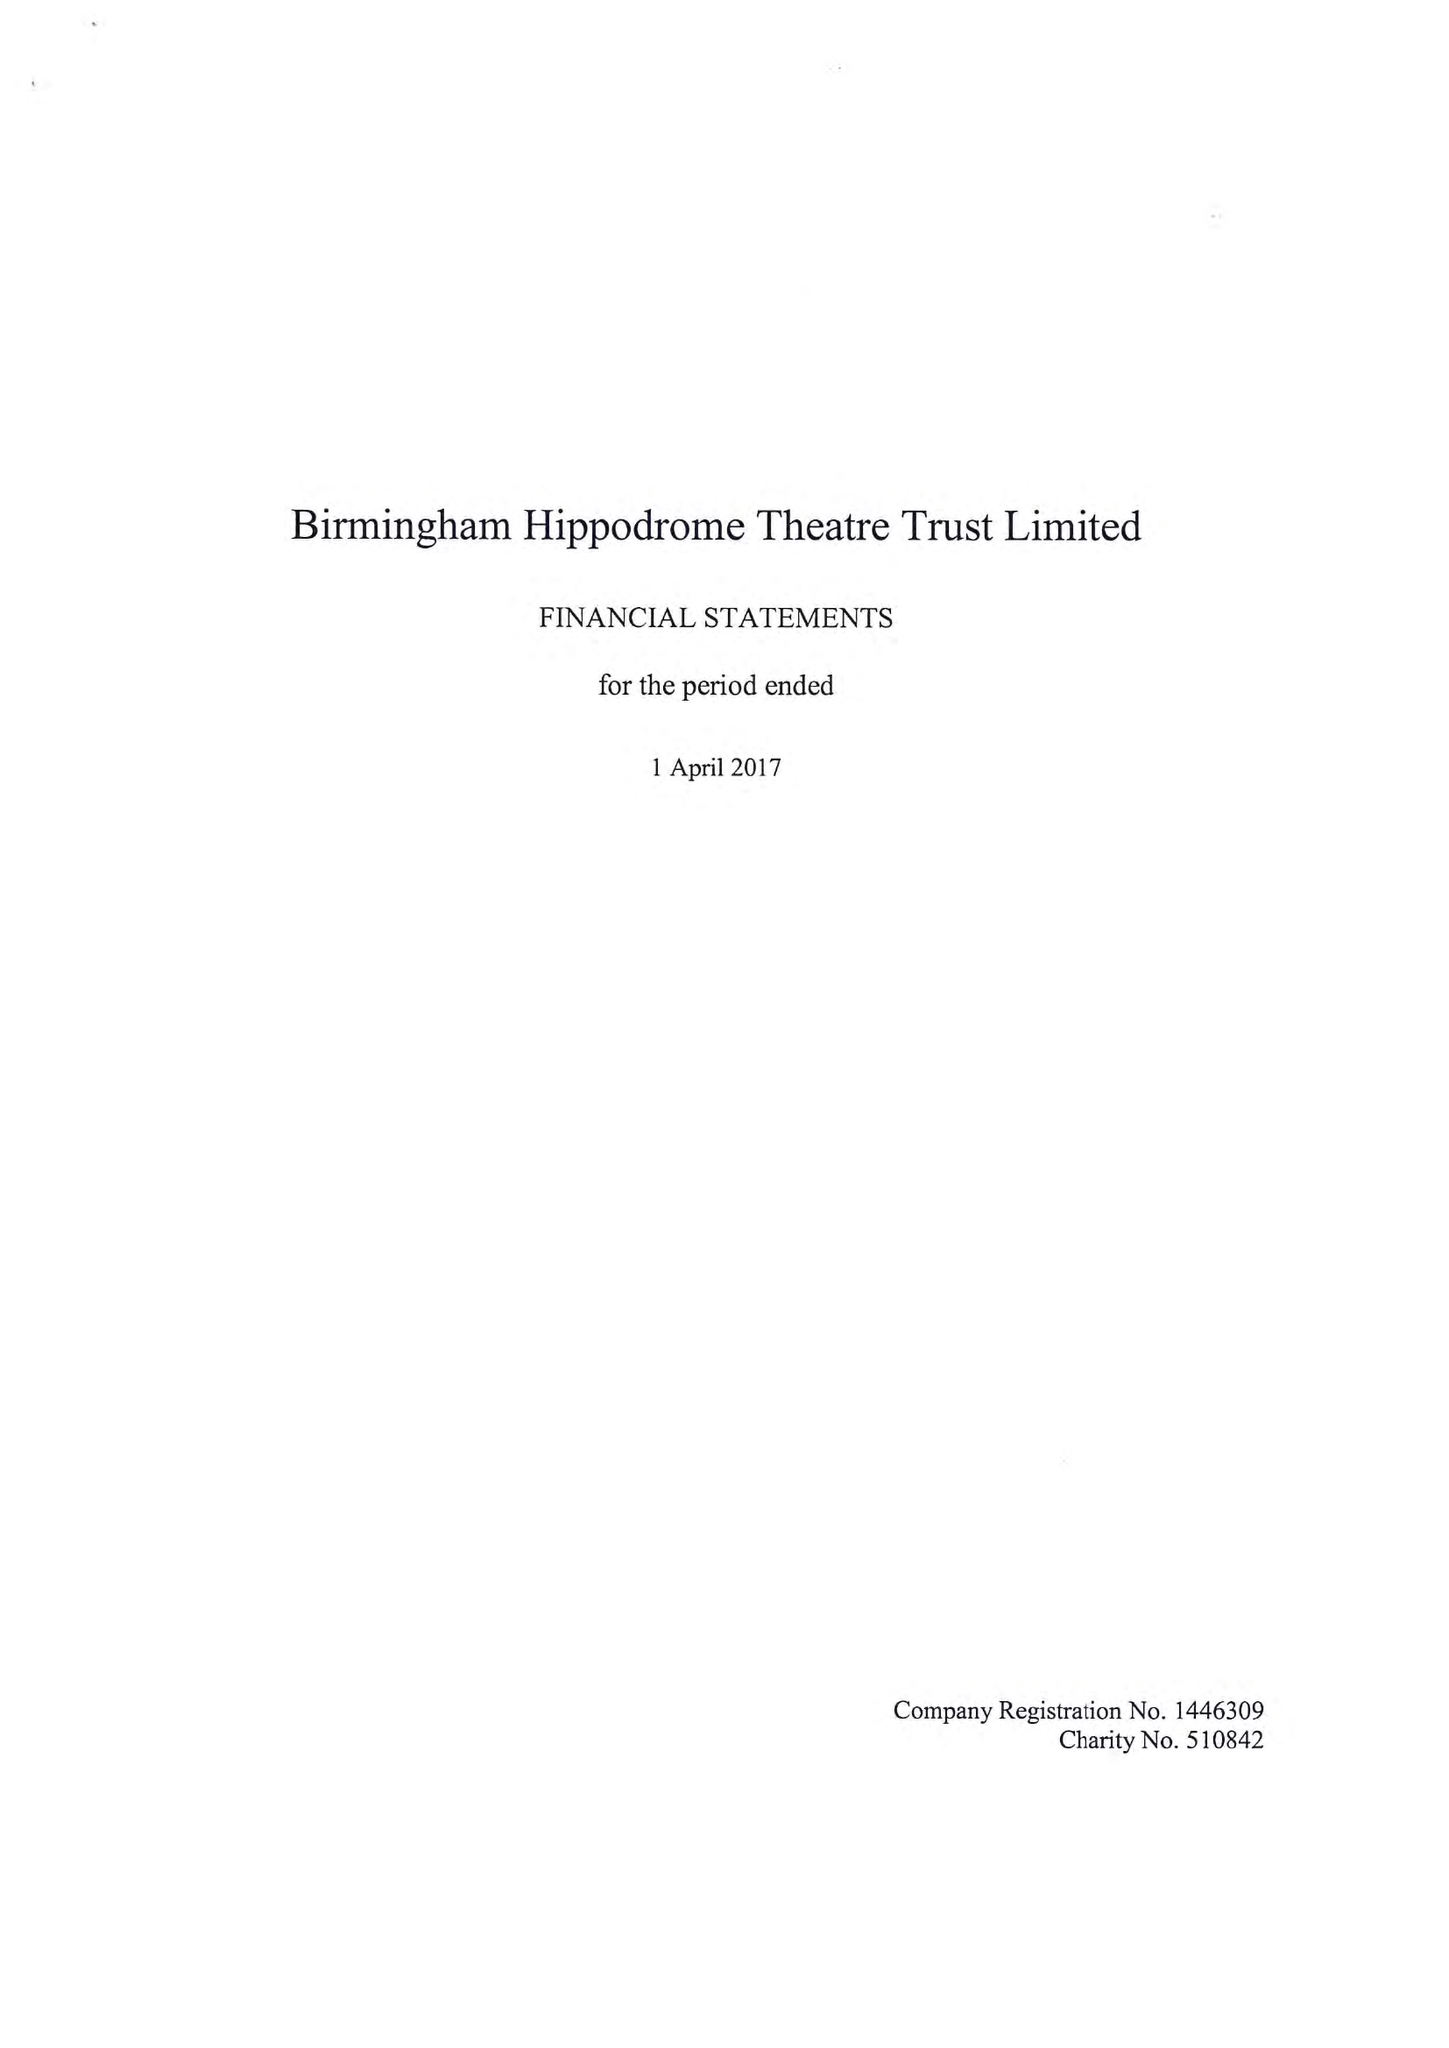What is the value for the address__postcode?
Answer the question using a single word or phrase. B5 4TB 